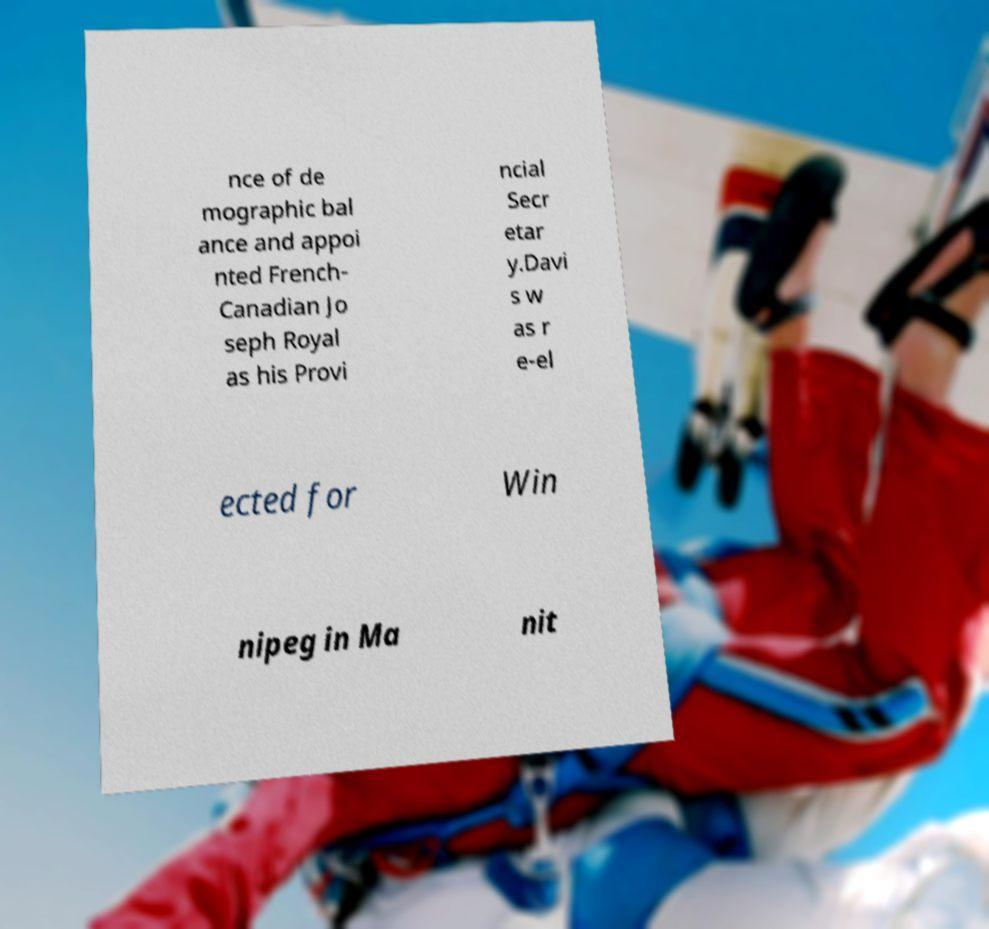What messages or text are displayed in this image? I need them in a readable, typed format. nce of de mographic bal ance and appoi nted French- Canadian Jo seph Royal as his Provi ncial Secr etar y.Davi s w as r e-el ected for Win nipeg in Ma nit 